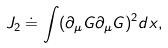Convert formula to latex. <formula><loc_0><loc_0><loc_500><loc_500>J _ { 2 } \doteq \int ( \partial _ { \mu } G \partial _ { \mu } G ) ^ { 2 } d x ,</formula> 